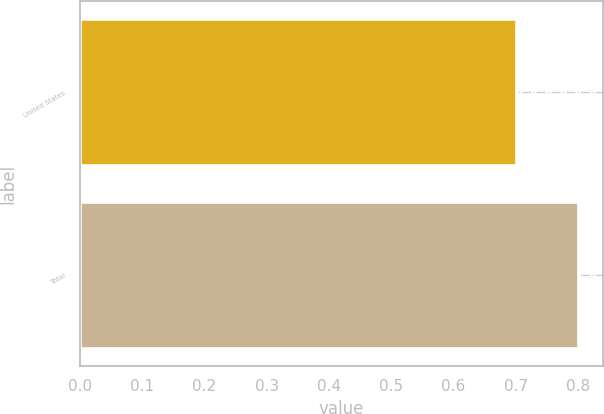Convert chart. <chart><loc_0><loc_0><loc_500><loc_500><bar_chart><fcel>United States<fcel>Total<nl><fcel>0.7<fcel>0.8<nl></chart> 